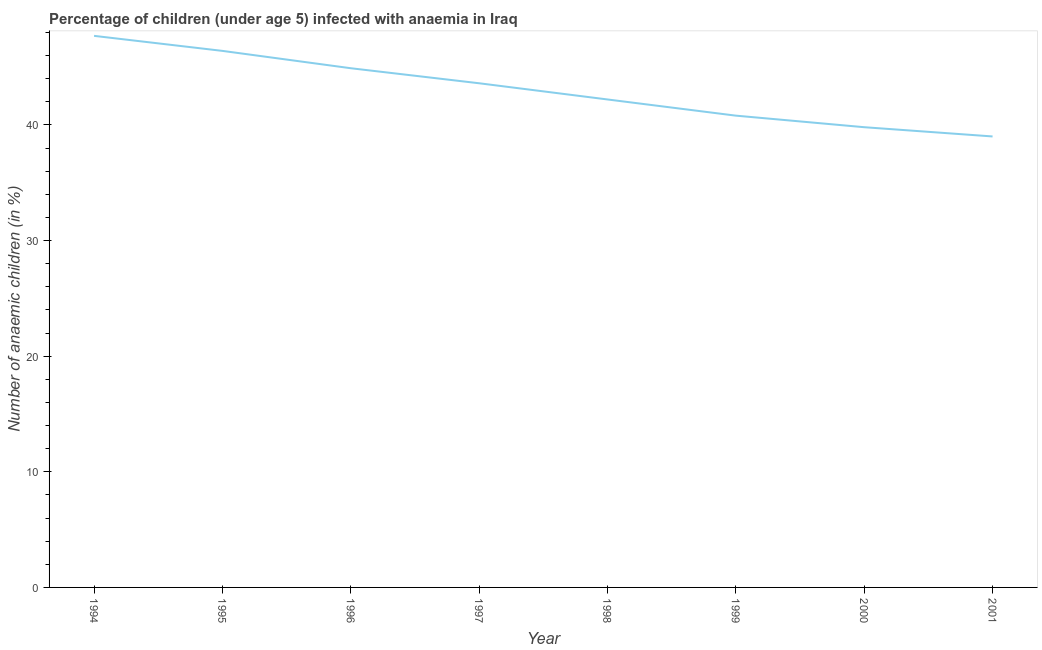What is the number of anaemic children in 1997?
Offer a very short reply. 43.6. Across all years, what is the maximum number of anaemic children?
Offer a very short reply. 47.7. What is the sum of the number of anaemic children?
Provide a short and direct response. 344.4. What is the difference between the number of anaemic children in 1994 and 1997?
Your answer should be compact. 4.1. What is the average number of anaemic children per year?
Provide a short and direct response. 43.05. What is the median number of anaemic children?
Make the answer very short. 42.9. In how many years, is the number of anaemic children greater than 46 %?
Ensure brevity in your answer.  2. What is the ratio of the number of anaemic children in 1997 to that in 2000?
Provide a short and direct response. 1.1. Is the difference between the number of anaemic children in 1995 and 1997 greater than the difference between any two years?
Give a very brief answer. No. What is the difference between the highest and the second highest number of anaemic children?
Keep it short and to the point. 1.3. What is the difference between the highest and the lowest number of anaemic children?
Your answer should be compact. 8.7. How many years are there in the graph?
Your answer should be very brief. 8. What is the difference between two consecutive major ticks on the Y-axis?
Provide a short and direct response. 10. Are the values on the major ticks of Y-axis written in scientific E-notation?
Offer a terse response. No. Does the graph contain any zero values?
Provide a succinct answer. No. Does the graph contain grids?
Ensure brevity in your answer.  No. What is the title of the graph?
Make the answer very short. Percentage of children (under age 5) infected with anaemia in Iraq. What is the label or title of the Y-axis?
Give a very brief answer. Number of anaemic children (in %). What is the Number of anaemic children (in %) of 1994?
Make the answer very short. 47.7. What is the Number of anaemic children (in %) in 1995?
Make the answer very short. 46.4. What is the Number of anaemic children (in %) of 1996?
Your response must be concise. 44.9. What is the Number of anaemic children (in %) of 1997?
Make the answer very short. 43.6. What is the Number of anaemic children (in %) of 1998?
Ensure brevity in your answer.  42.2. What is the Number of anaemic children (in %) in 1999?
Provide a succinct answer. 40.8. What is the Number of anaemic children (in %) of 2000?
Keep it short and to the point. 39.8. What is the difference between the Number of anaemic children (in %) in 1994 and 1995?
Keep it short and to the point. 1.3. What is the difference between the Number of anaemic children (in %) in 1994 and 1996?
Provide a succinct answer. 2.8. What is the difference between the Number of anaemic children (in %) in 1994 and 1997?
Your response must be concise. 4.1. What is the difference between the Number of anaemic children (in %) in 1994 and 1998?
Offer a terse response. 5.5. What is the difference between the Number of anaemic children (in %) in 1994 and 1999?
Keep it short and to the point. 6.9. What is the difference between the Number of anaemic children (in %) in 1994 and 2000?
Offer a terse response. 7.9. What is the difference between the Number of anaemic children (in %) in 1995 and 1997?
Offer a terse response. 2.8. What is the difference between the Number of anaemic children (in %) in 1995 and 1998?
Keep it short and to the point. 4.2. What is the difference between the Number of anaemic children (in %) in 1995 and 2001?
Offer a terse response. 7.4. What is the difference between the Number of anaemic children (in %) in 1996 and 1997?
Provide a succinct answer. 1.3. What is the difference between the Number of anaemic children (in %) in 1996 and 1999?
Make the answer very short. 4.1. What is the difference between the Number of anaemic children (in %) in 1996 and 2000?
Your answer should be compact. 5.1. What is the difference between the Number of anaemic children (in %) in 1997 and 1998?
Offer a very short reply. 1.4. What is the difference between the Number of anaemic children (in %) in 1997 and 2000?
Your answer should be compact. 3.8. What is the difference between the Number of anaemic children (in %) in 1997 and 2001?
Your response must be concise. 4.6. What is the difference between the Number of anaemic children (in %) in 1998 and 1999?
Your response must be concise. 1.4. What is the difference between the Number of anaemic children (in %) in 1999 and 2000?
Offer a very short reply. 1. What is the difference between the Number of anaemic children (in %) in 2000 and 2001?
Your response must be concise. 0.8. What is the ratio of the Number of anaemic children (in %) in 1994 to that in 1995?
Make the answer very short. 1.03. What is the ratio of the Number of anaemic children (in %) in 1994 to that in 1996?
Offer a very short reply. 1.06. What is the ratio of the Number of anaemic children (in %) in 1994 to that in 1997?
Ensure brevity in your answer.  1.09. What is the ratio of the Number of anaemic children (in %) in 1994 to that in 1998?
Keep it short and to the point. 1.13. What is the ratio of the Number of anaemic children (in %) in 1994 to that in 1999?
Offer a very short reply. 1.17. What is the ratio of the Number of anaemic children (in %) in 1994 to that in 2000?
Offer a terse response. 1.2. What is the ratio of the Number of anaemic children (in %) in 1994 to that in 2001?
Provide a short and direct response. 1.22. What is the ratio of the Number of anaemic children (in %) in 1995 to that in 1996?
Your response must be concise. 1.03. What is the ratio of the Number of anaemic children (in %) in 1995 to that in 1997?
Make the answer very short. 1.06. What is the ratio of the Number of anaemic children (in %) in 1995 to that in 1998?
Ensure brevity in your answer.  1.1. What is the ratio of the Number of anaemic children (in %) in 1995 to that in 1999?
Offer a terse response. 1.14. What is the ratio of the Number of anaemic children (in %) in 1995 to that in 2000?
Ensure brevity in your answer.  1.17. What is the ratio of the Number of anaemic children (in %) in 1995 to that in 2001?
Offer a very short reply. 1.19. What is the ratio of the Number of anaemic children (in %) in 1996 to that in 1997?
Give a very brief answer. 1.03. What is the ratio of the Number of anaemic children (in %) in 1996 to that in 1998?
Provide a short and direct response. 1.06. What is the ratio of the Number of anaemic children (in %) in 1996 to that in 1999?
Keep it short and to the point. 1.1. What is the ratio of the Number of anaemic children (in %) in 1996 to that in 2000?
Your answer should be compact. 1.13. What is the ratio of the Number of anaemic children (in %) in 1996 to that in 2001?
Your answer should be compact. 1.15. What is the ratio of the Number of anaemic children (in %) in 1997 to that in 1998?
Make the answer very short. 1.03. What is the ratio of the Number of anaemic children (in %) in 1997 to that in 1999?
Provide a short and direct response. 1.07. What is the ratio of the Number of anaemic children (in %) in 1997 to that in 2000?
Ensure brevity in your answer.  1.09. What is the ratio of the Number of anaemic children (in %) in 1997 to that in 2001?
Give a very brief answer. 1.12. What is the ratio of the Number of anaemic children (in %) in 1998 to that in 1999?
Offer a very short reply. 1.03. What is the ratio of the Number of anaemic children (in %) in 1998 to that in 2000?
Give a very brief answer. 1.06. What is the ratio of the Number of anaemic children (in %) in 1998 to that in 2001?
Your response must be concise. 1.08. What is the ratio of the Number of anaemic children (in %) in 1999 to that in 2001?
Make the answer very short. 1.05. What is the ratio of the Number of anaemic children (in %) in 2000 to that in 2001?
Ensure brevity in your answer.  1.02. 